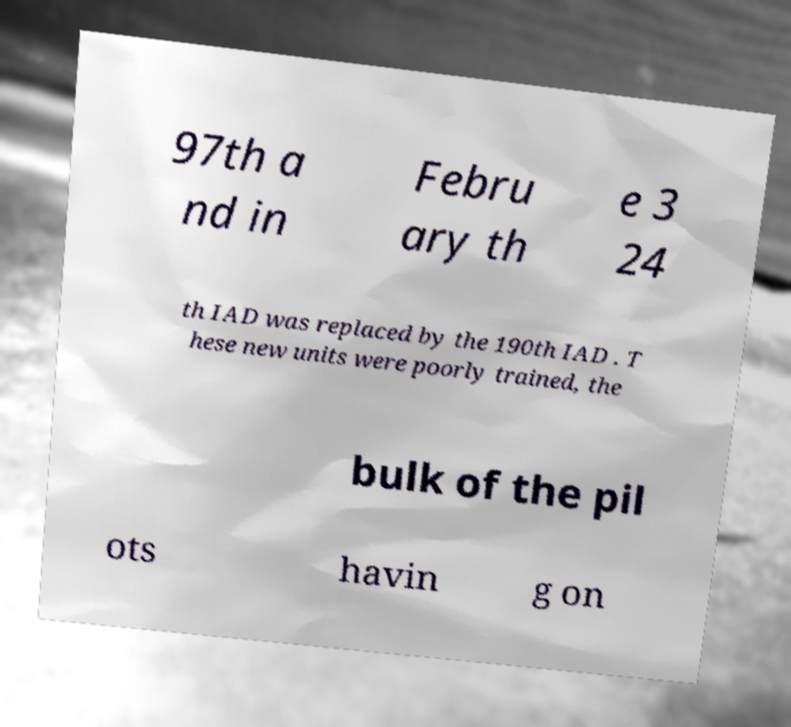For documentation purposes, I need the text within this image transcribed. Could you provide that? 97th a nd in Febru ary th e 3 24 th IAD was replaced by the 190th IAD . T hese new units were poorly trained, the bulk of the pil ots havin g on 